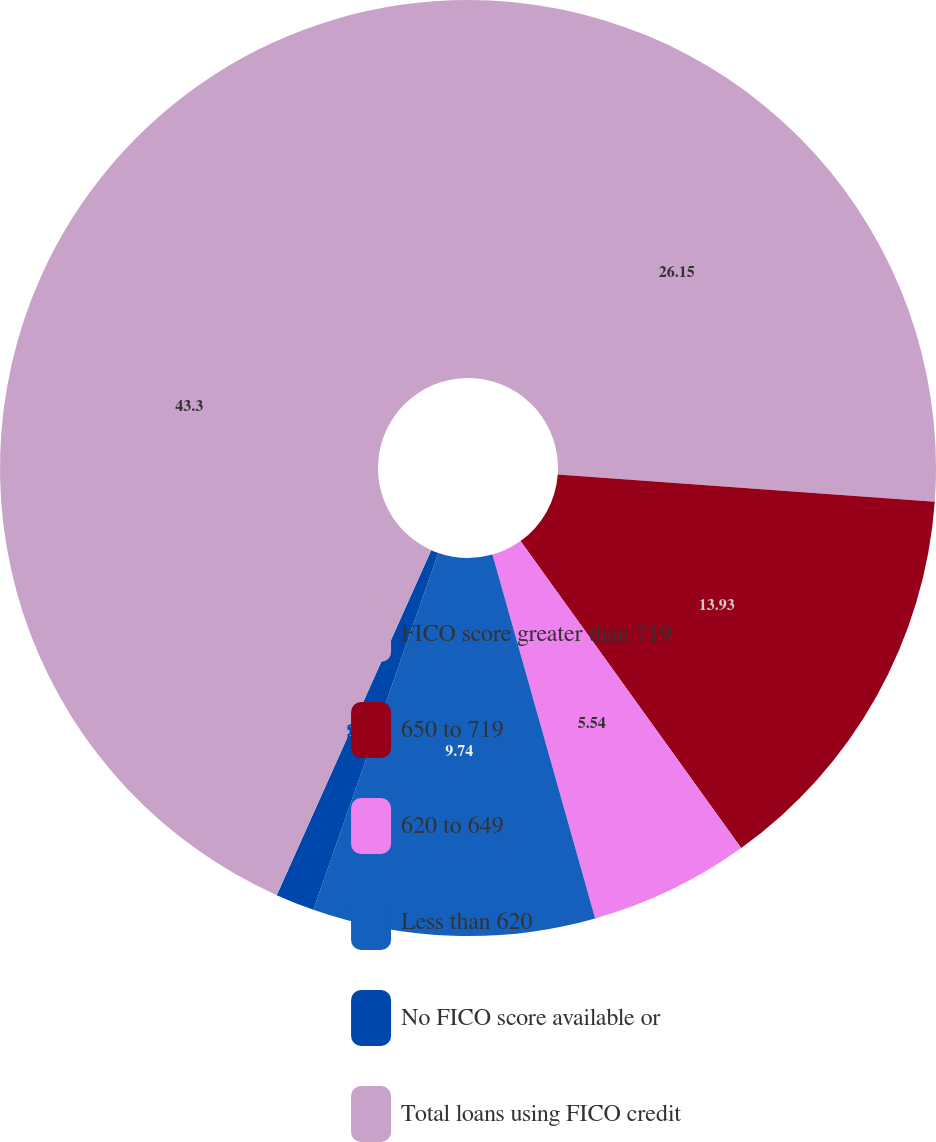Convert chart to OTSL. <chart><loc_0><loc_0><loc_500><loc_500><pie_chart><fcel>FICO score greater than 719<fcel>650 to 719<fcel>620 to 649<fcel>Less than 620<fcel>No FICO score available or<fcel>Total loans using FICO credit<nl><fcel>26.15%<fcel>13.93%<fcel>5.54%<fcel>9.74%<fcel>1.34%<fcel>43.3%<nl></chart> 